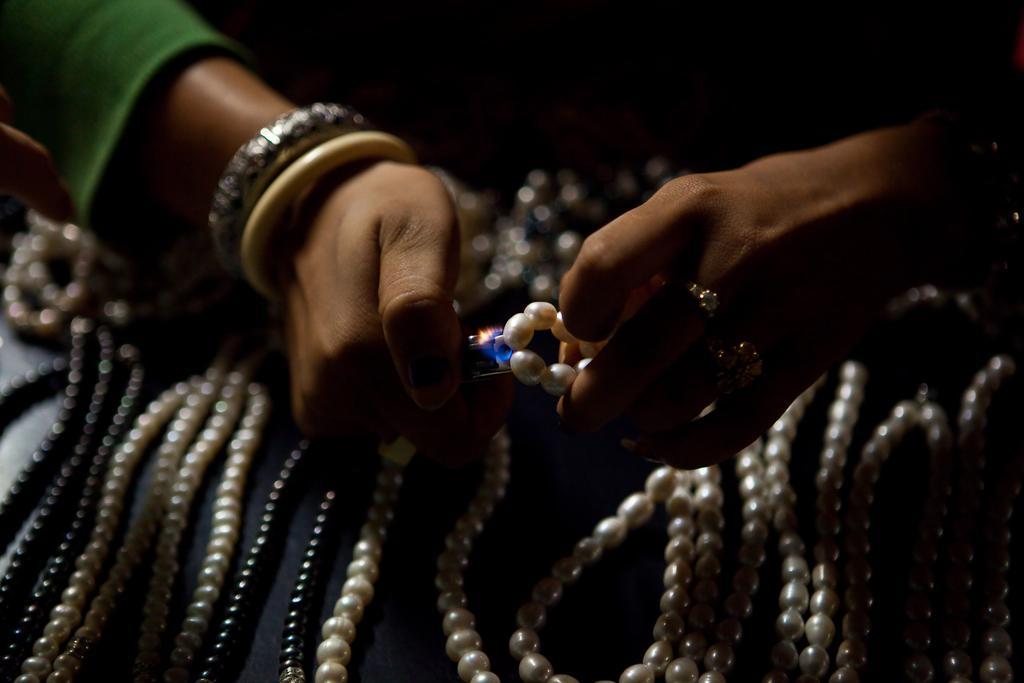Describe this image in one or two sentences. In this image we can see hands of a person holding a pearl chain and another object. Here we can see pearl chains on a platform. 